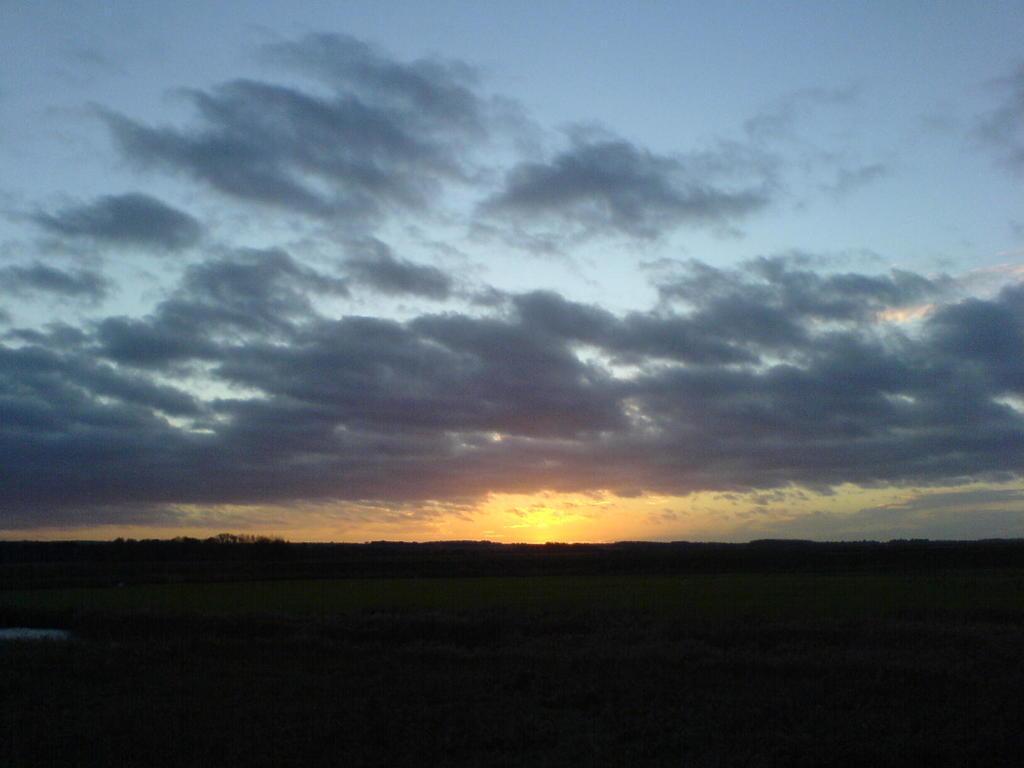How would you summarize this image in a sentence or two? In this image I can see the sky. This image is little bit dark. 